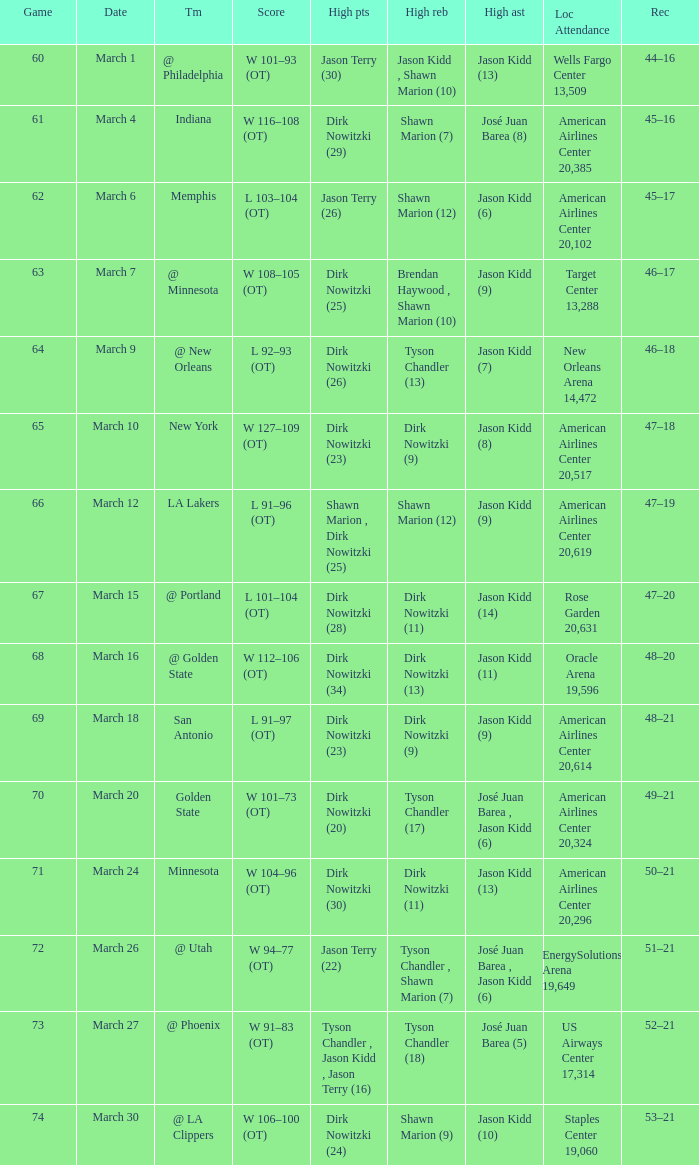Name the score for  josé juan barea (8) W 116–108 (OT). 